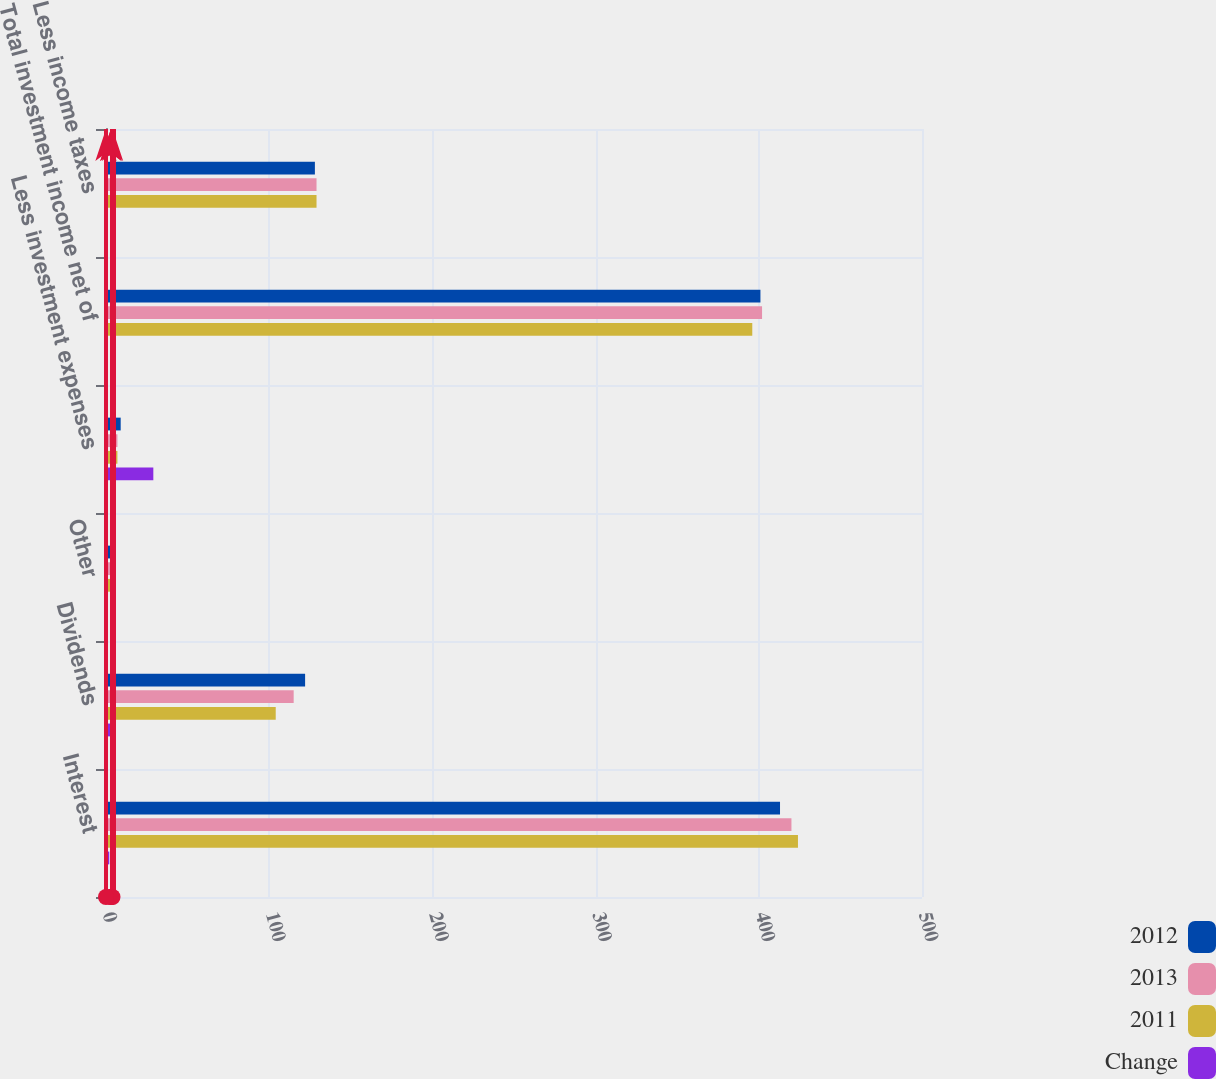<chart> <loc_0><loc_0><loc_500><loc_500><stacked_bar_chart><ecel><fcel>Interest<fcel>Dividends<fcel>Other<fcel>Less investment expenses<fcel>Total investment income net of<fcel>Less income taxes<nl><fcel>2012<fcel>413<fcel>122<fcel>3<fcel>9<fcel>401<fcel>128<nl><fcel>2013<fcel>420<fcel>115<fcel>3<fcel>7<fcel>402<fcel>129<nl><fcel>2011<fcel>424<fcel>104<fcel>4<fcel>7<fcel>396<fcel>129<nl><fcel>Change<fcel>2<fcel>6<fcel>0<fcel>29<fcel>0<fcel>1<nl></chart> 